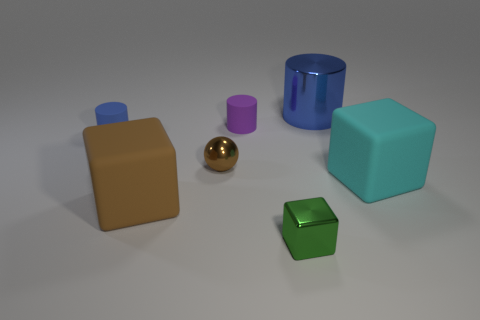Subtract all purple matte cylinders. How many cylinders are left? 2 Subtract all brown cubes. How many cubes are left? 2 Subtract all cubes. How many objects are left? 4 Add 4 tiny blue matte cylinders. How many tiny blue matte cylinders are left? 5 Add 2 tiny brown metal things. How many tiny brown metal things exist? 3 Add 2 brown metal spheres. How many objects exist? 9 Subtract 0 red cylinders. How many objects are left? 7 Subtract 1 balls. How many balls are left? 0 Subtract all yellow spheres. Subtract all green cylinders. How many spheres are left? 1 Subtract all gray cylinders. How many green cubes are left? 1 